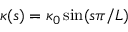Convert formula to latex. <formula><loc_0><loc_0><loc_500><loc_500>\kappa ( s ) = \kappa _ { 0 } \sin ( s \pi / L )</formula> 